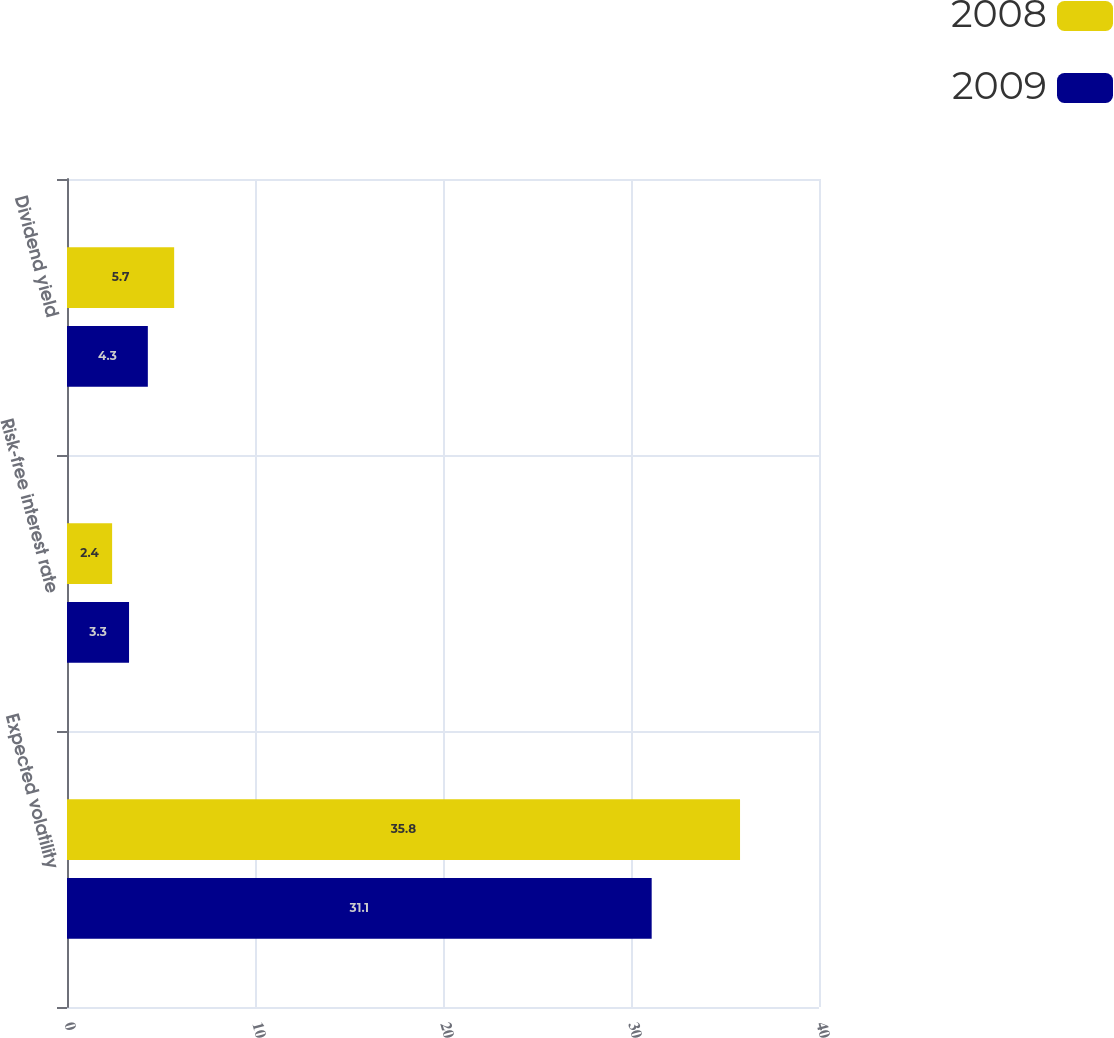Convert chart. <chart><loc_0><loc_0><loc_500><loc_500><stacked_bar_chart><ecel><fcel>Expected volatility<fcel>Risk-free interest rate<fcel>Dividend yield<nl><fcel>2008<fcel>35.8<fcel>2.4<fcel>5.7<nl><fcel>2009<fcel>31.1<fcel>3.3<fcel>4.3<nl></chart> 